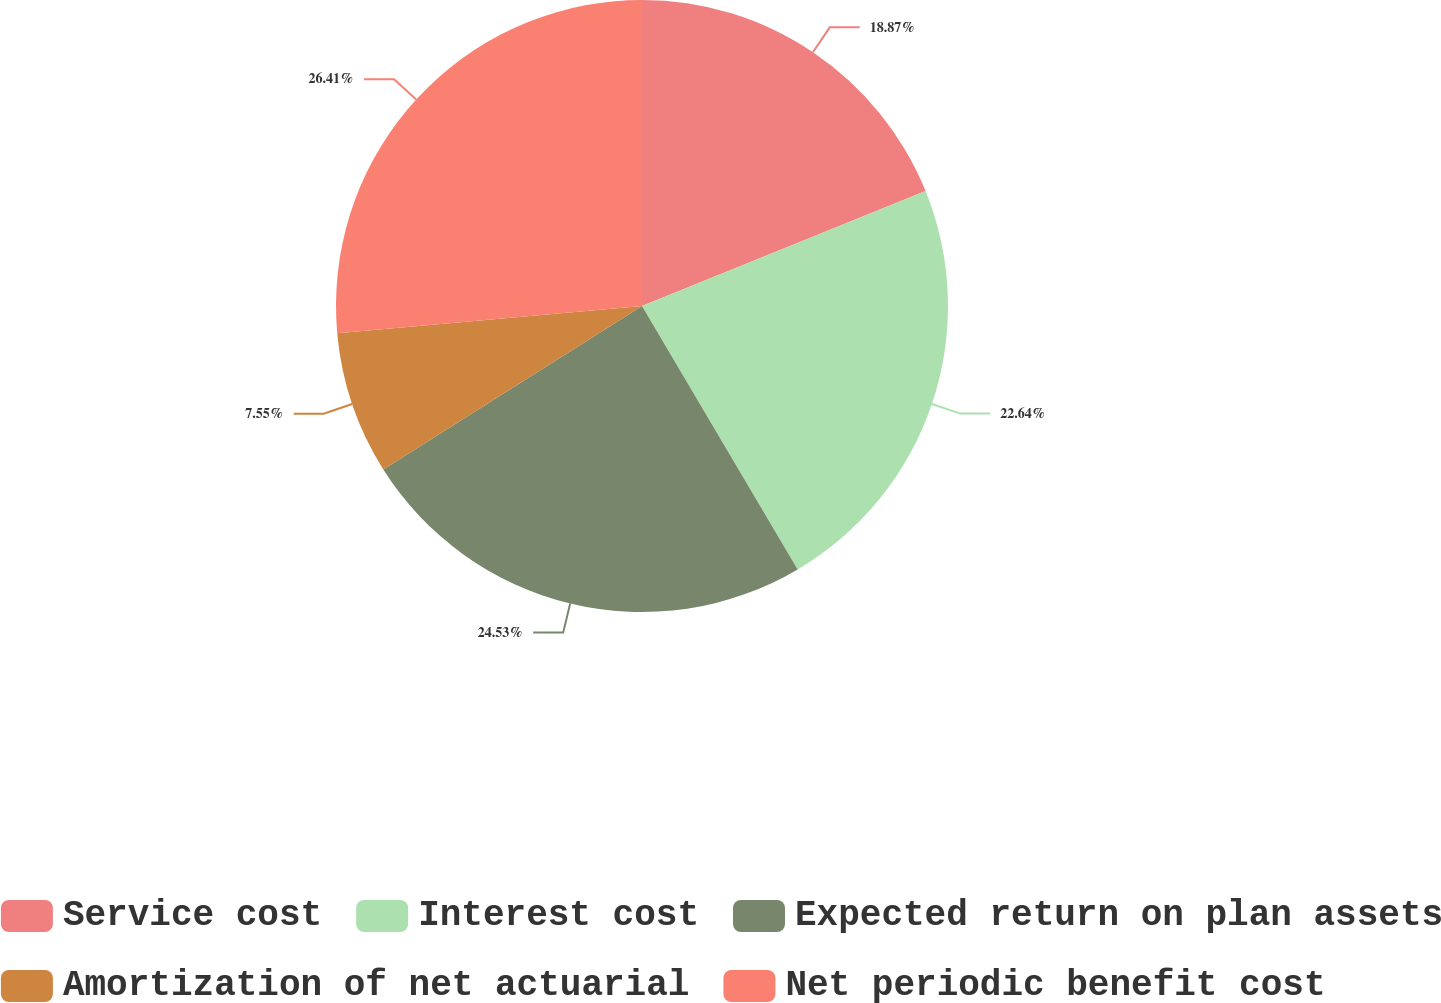<chart> <loc_0><loc_0><loc_500><loc_500><pie_chart><fcel>Service cost<fcel>Interest cost<fcel>Expected return on plan assets<fcel>Amortization of net actuarial<fcel>Net periodic benefit cost<nl><fcel>18.87%<fcel>22.64%<fcel>24.53%<fcel>7.55%<fcel>26.42%<nl></chart> 